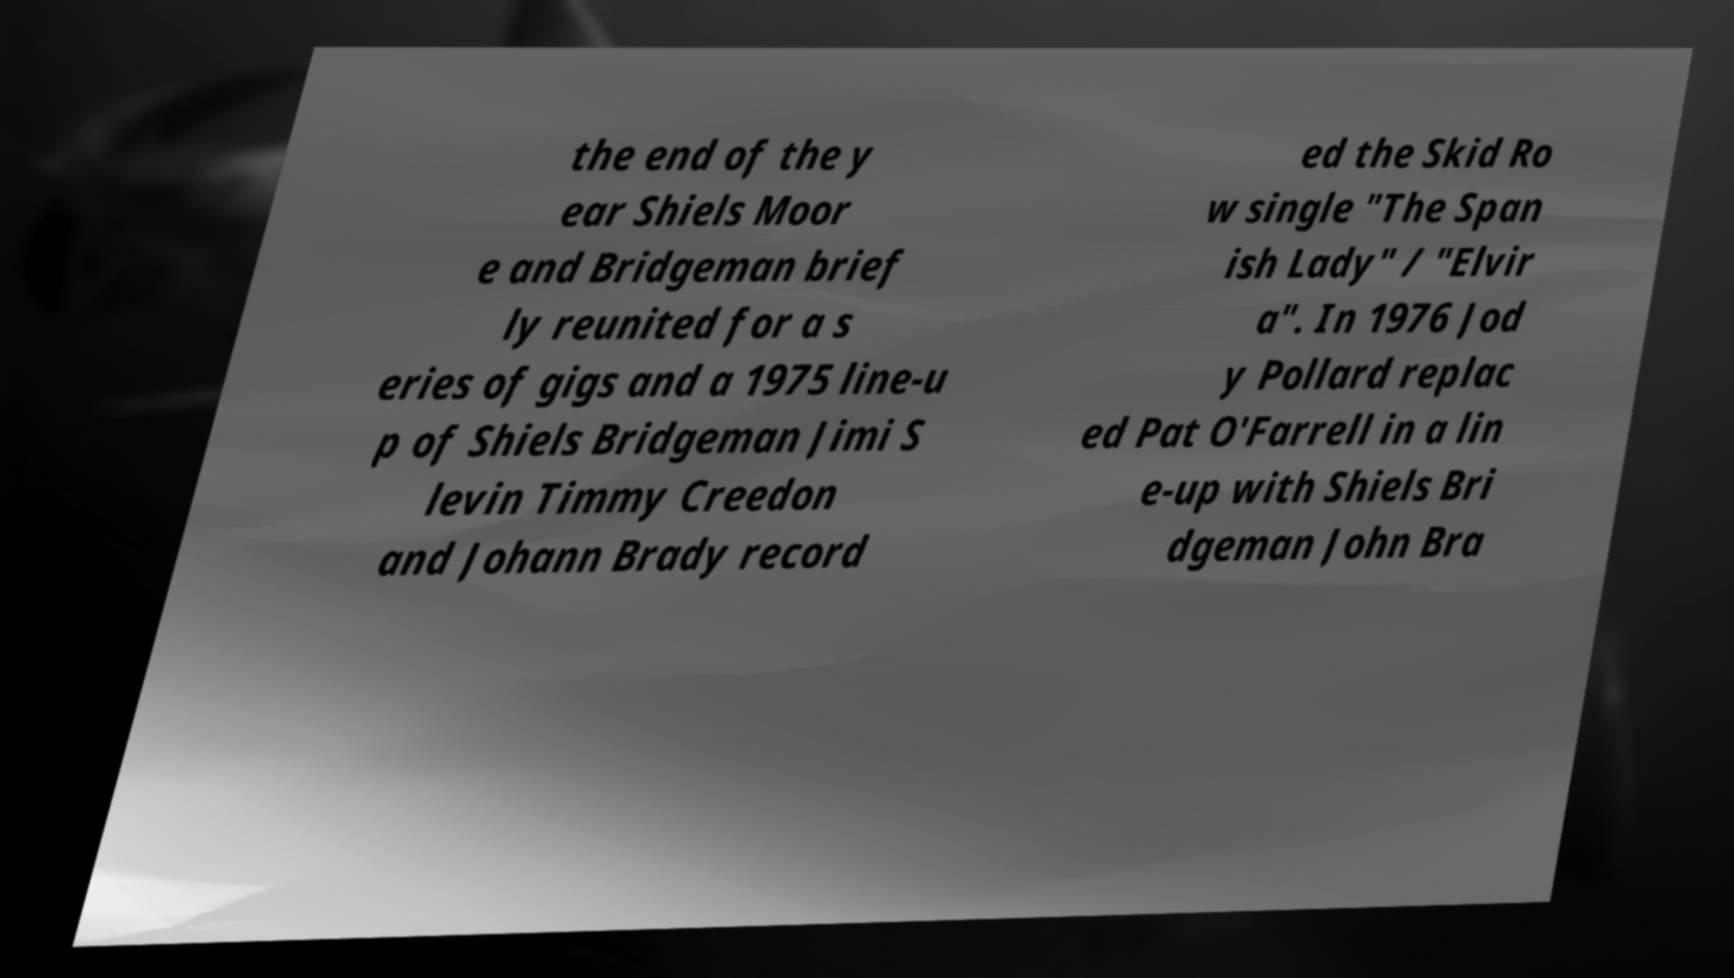Please identify and transcribe the text found in this image. the end of the y ear Shiels Moor e and Bridgeman brief ly reunited for a s eries of gigs and a 1975 line-u p of Shiels Bridgeman Jimi S levin Timmy Creedon and Johann Brady record ed the Skid Ro w single "The Span ish Lady" / "Elvir a". In 1976 Jod y Pollard replac ed Pat O'Farrell in a lin e-up with Shiels Bri dgeman John Bra 